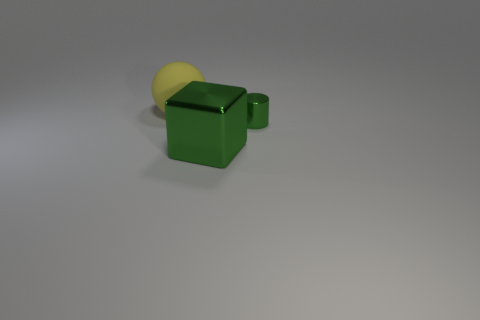Add 3 tiny yellow matte objects. How many objects exist? 6 Subtract all cubes. How many objects are left? 2 Subtract all yellow cylinders. Subtract all yellow balls. How many cylinders are left? 1 Subtract all large blue shiny things. Subtract all blocks. How many objects are left? 2 Add 3 shiny cylinders. How many shiny cylinders are left? 4 Add 2 big metal blocks. How many big metal blocks exist? 3 Subtract 0 purple spheres. How many objects are left? 3 Subtract 1 cylinders. How many cylinders are left? 0 